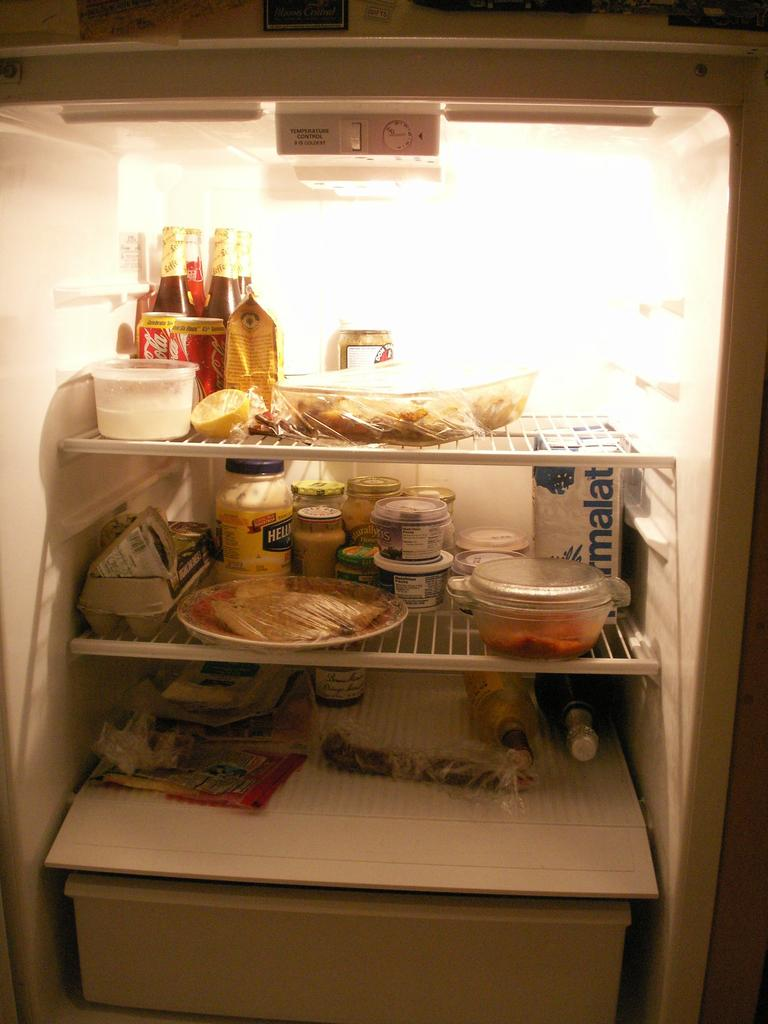<image>
Render a clear and concise summary of the photo. An open and full refrigerator contains items such as Coca-Cola and Hellman's Mayo. 